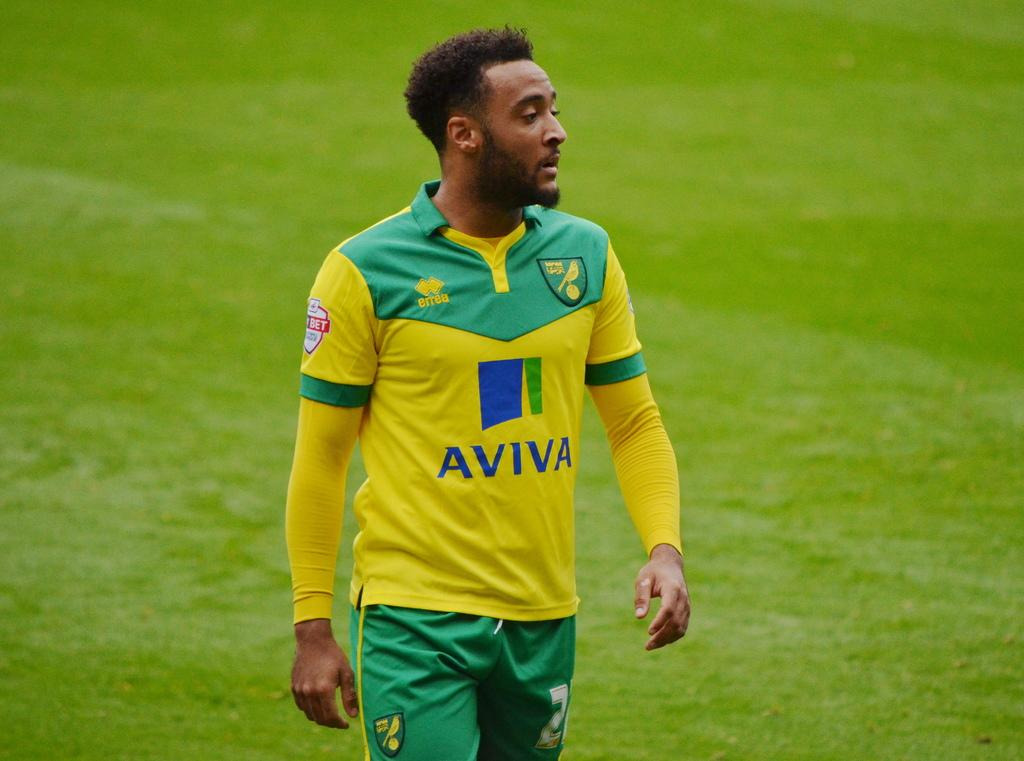Provide a one-sentence caption for the provided image. Athlete standing on grass wearing an "AVIVA" jersey. 